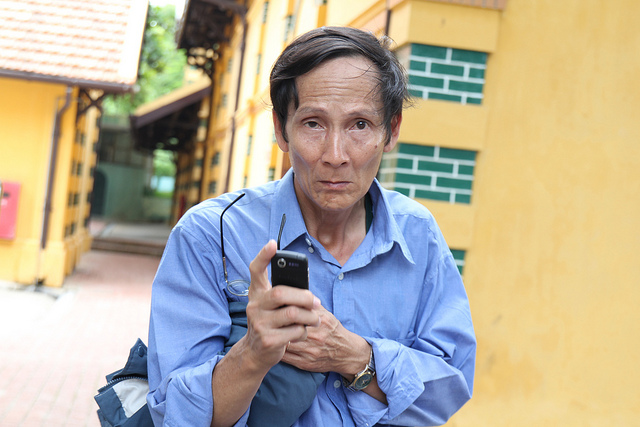<image>Is the man satisfied? I don't know if the man is satisfied. Is the man satisfied? I don't know if the man is satisfied. It seems like he is not satisfied as most of the answers are 'no'. 